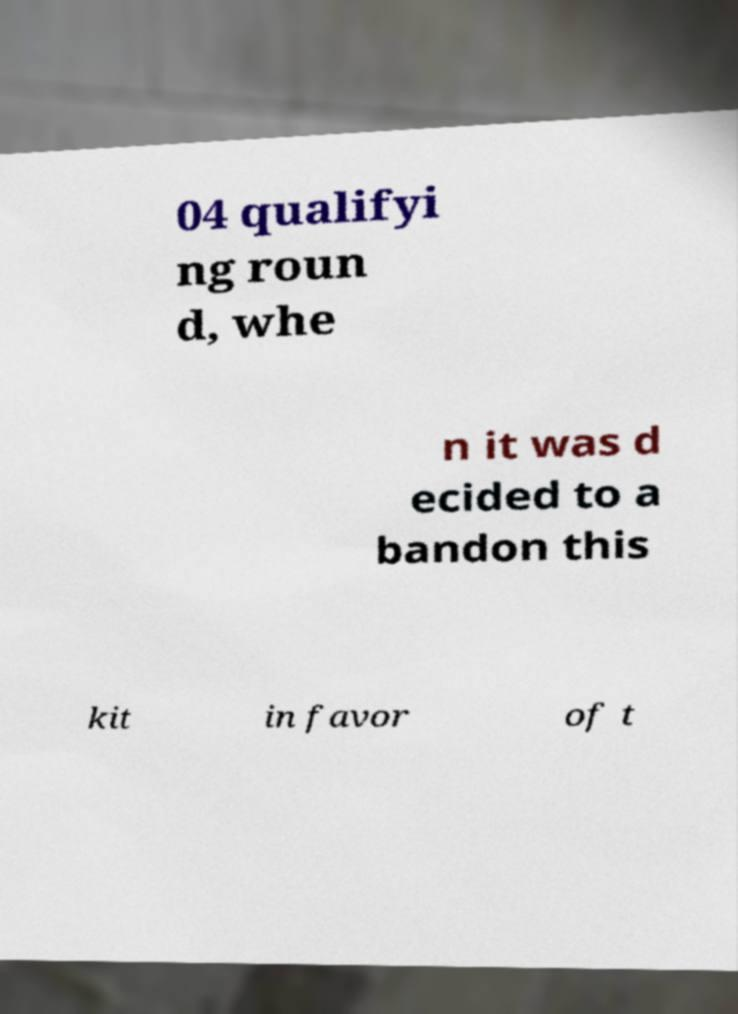Could you assist in decoding the text presented in this image and type it out clearly? 04 qualifyi ng roun d, whe n it was d ecided to a bandon this kit in favor of t 